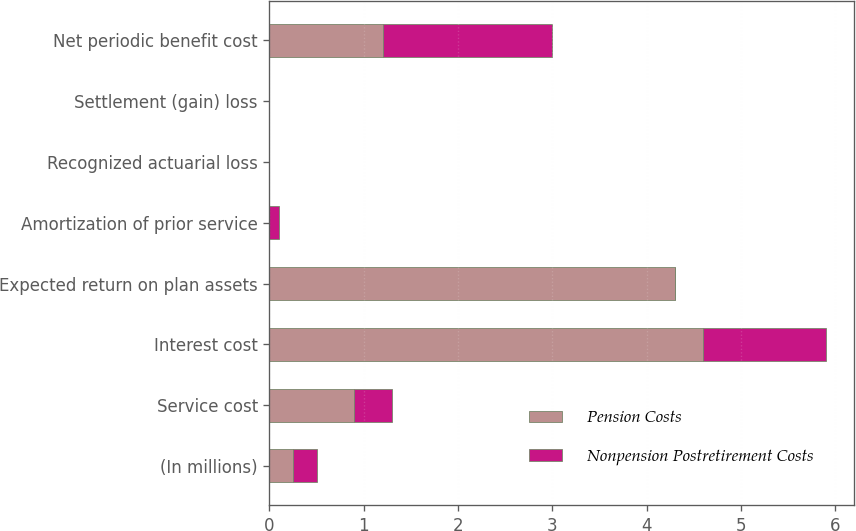Convert chart. <chart><loc_0><loc_0><loc_500><loc_500><stacked_bar_chart><ecel><fcel>(In millions)<fcel>Service cost<fcel>Interest cost<fcel>Expected return on plan assets<fcel>Amortization of prior service<fcel>Recognized actuarial loss<fcel>Settlement (gain) loss<fcel>Net periodic benefit cost<nl><fcel>Pension Costs<fcel>0.25<fcel>0.9<fcel>4.6<fcel>4.3<fcel>0<fcel>0<fcel>0<fcel>1.2<nl><fcel>Nonpension Postretirement Costs<fcel>0.25<fcel>0.4<fcel>1.3<fcel>0<fcel>0.1<fcel>0<fcel>0<fcel>1.8<nl></chart> 